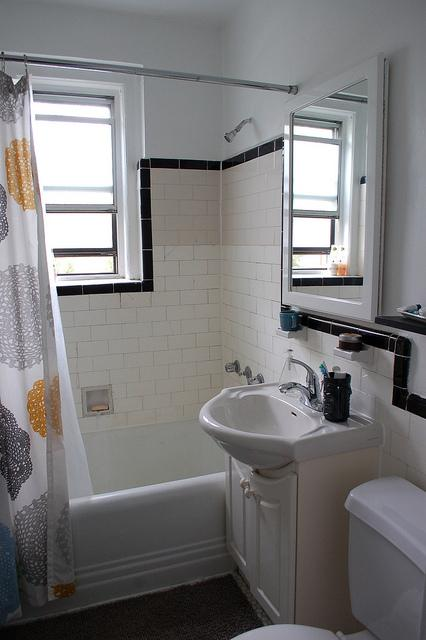What is one of the colors on the curtain?

Choices:
A) red
B) purple
C) yellow
D) blue yellow 